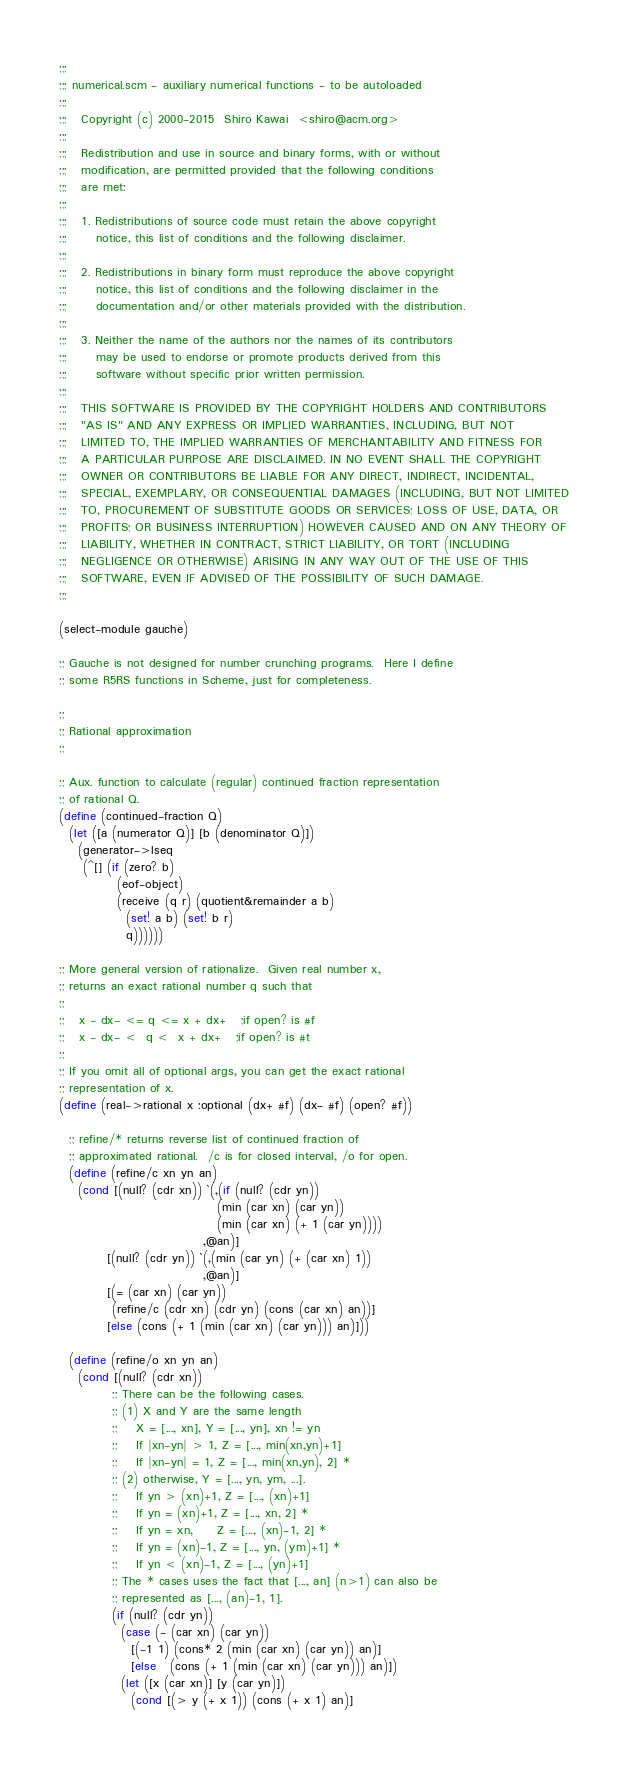Convert code to text. <code><loc_0><loc_0><loc_500><loc_500><_Scheme_>;;;
;;; numerical.scm - auxiliary numerical functions - to be autoloaded
;;;
;;;   Copyright (c) 2000-2015  Shiro Kawai  <shiro@acm.org>
;;;
;;;   Redistribution and use in source and binary forms, with or without
;;;   modification, are permitted provided that the following conditions
;;;   are met:
;;;
;;;   1. Redistributions of source code must retain the above copyright
;;;      notice, this list of conditions and the following disclaimer.
;;;
;;;   2. Redistributions in binary form must reproduce the above copyright
;;;      notice, this list of conditions and the following disclaimer in the
;;;      documentation and/or other materials provided with the distribution.
;;;
;;;   3. Neither the name of the authors nor the names of its contributors
;;;      may be used to endorse or promote products derived from this
;;;      software without specific prior written permission.
;;;
;;;   THIS SOFTWARE IS PROVIDED BY THE COPYRIGHT HOLDERS AND CONTRIBUTORS
;;;   "AS IS" AND ANY EXPRESS OR IMPLIED WARRANTIES, INCLUDING, BUT NOT
;;;   LIMITED TO, THE IMPLIED WARRANTIES OF MERCHANTABILITY AND FITNESS FOR
;;;   A PARTICULAR PURPOSE ARE DISCLAIMED. IN NO EVENT SHALL THE COPYRIGHT
;;;   OWNER OR CONTRIBUTORS BE LIABLE FOR ANY DIRECT, INDIRECT, INCIDENTAL,
;;;   SPECIAL, EXEMPLARY, OR CONSEQUENTIAL DAMAGES (INCLUDING, BUT NOT LIMITED
;;;   TO, PROCUREMENT OF SUBSTITUTE GOODS OR SERVICES; LOSS OF USE, DATA, OR
;;;   PROFITS; OR BUSINESS INTERRUPTION) HOWEVER CAUSED AND ON ANY THEORY OF
;;;   LIABILITY, WHETHER IN CONTRACT, STRICT LIABILITY, OR TORT (INCLUDING
;;;   NEGLIGENCE OR OTHERWISE) ARISING IN ANY WAY OUT OF THE USE OF THIS
;;;   SOFTWARE, EVEN IF ADVISED OF THE POSSIBILITY OF SUCH DAMAGE.
;;;

(select-module gauche)

;; Gauche is not designed for number crunching programs.  Here I define
;; some R5RS functions in Scheme, just for completeness.

;;
;; Rational approximation
;;

;; Aux. function to calculate (regular) continued fraction representation
;; of rational Q.
(define (continued-fraction Q)
  (let ([a (numerator Q)] [b (denominator Q)])
    (generator->lseq
     (^[] (if (zero? b)
            (eof-object)
            (receive (q r) (quotient&remainder a b)
              (set! a b) (set! b r)
              q))))))

;; More general version of rationalize.  Given real number x,
;; returns an exact rational number q such that
;;
;;   x - dx- <= q <= x + dx+   ;if open? is #f
;;   x - dx- <  q <  x + dx+   ;if open? is #t
;;
;; If you omit all of optional args, you can get the exact rational
;; representation of x.
(define (real->rational x :optional (dx+ #f) (dx- #f) (open? #f))

  ;; refine/* returns reverse list of continued fraction of
  ;; approximated rational.  /c is for closed interval, /o for open.
  (define (refine/c xn yn an)
    (cond [(null? (cdr xn)) `(,(if (null? (cdr yn))
                                 (min (car xn) (car yn))
                                 (min (car xn) (+ 1 (car yn))))
                              ,@an)]
          [(null? (cdr yn)) `(,(min (car yn) (+ (car xn) 1))
                              ,@an)]
          [(= (car xn) (car yn))
           (refine/c (cdr xn) (cdr yn) (cons (car xn) an))]
          [else (cons (+ 1 (min (car xn) (car yn))) an)]))

  (define (refine/o xn yn an)
    (cond [(null? (cdr xn))
           ;; There can be the following cases.
           ;; (1) X and Y are the same length
           ;;    X = [..., xn], Y = [..., yn], xn != yn
           ;;    If |xn-yn| > 1, Z = [..., min(xn,yn)+1]
           ;;    If |xn-yn| = 1, Z = [..., min(xn,yn), 2] *
           ;; (2) otherwise, Y = [..., yn, ym, ...].
           ;;    If yn > (xn)+1, Z = [..., (xn)+1]
           ;;    If yn = (xn)+1, Z = [..., xn, 2] *
           ;;    If yn = xn,     Z = [..., (xn)-1, 2] *
           ;;    If yn = (xn)-1, Z = [..., yn, (ym)+1] *
           ;;    If yn < (xn)-1, Z = [..., (yn)+1]
           ;; The * cases uses the fact that [..., an] (n>1) can also be
           ;; represented as [..., (an)-1, 1].
           (if (null? (cdr yn))
             (case (- (car xn) (car yn))
               [(-1 1) (cons* 2 (min (car xn) (car yn)) an)]
               [else   (cons (+ 1 (min (car xn) (car yn))) an)])
             (let ([x (car xn)] [y (car yn)])
               (cond [(> y (+ x 1)) (cons (+ x 1) an)]</code> 